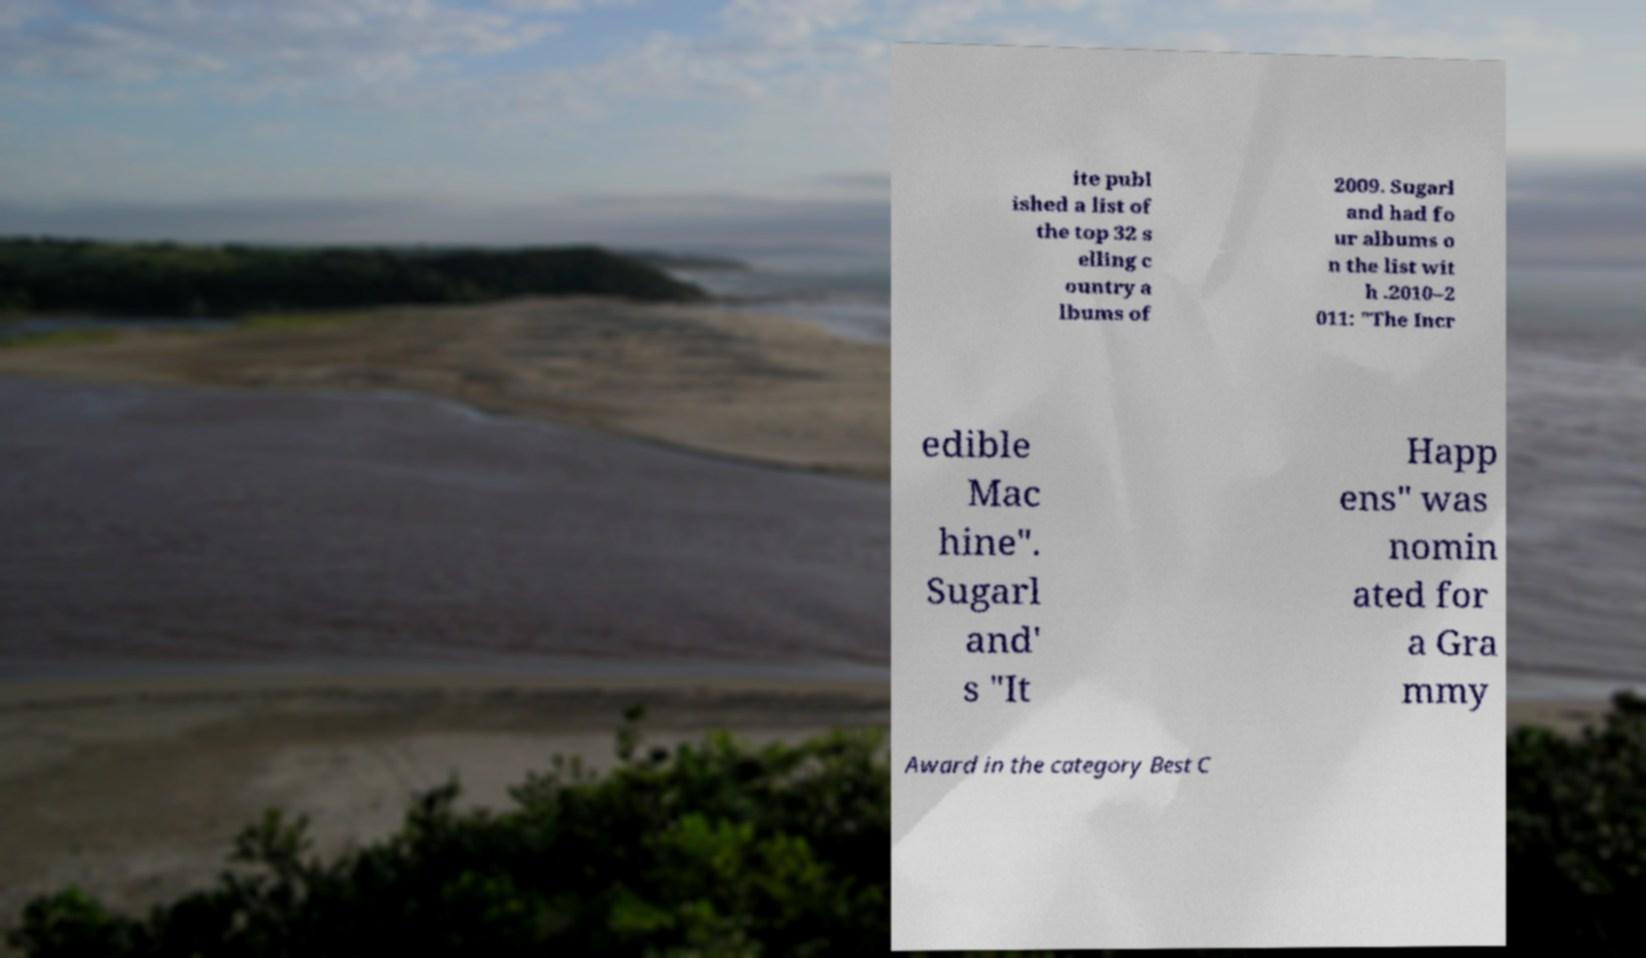What messages or text are displayed in this image? I need them in a readable, typed format. ite publ ished a list of the top 32 s elling c ountry a lbums of 2009. Sugarl and had fo ur albums o n the list wit h .2010–2 011: "The Incr edible Mac hine". Sugarl and' s "It Happ ens" was nomin ated for a Gra mmy Award in the category Best C 